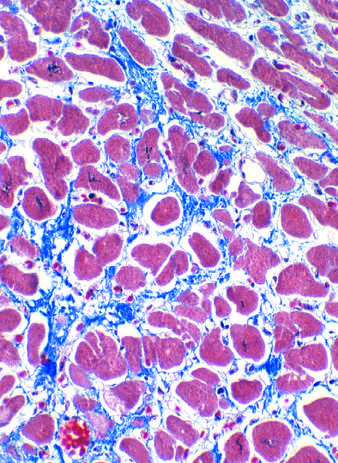what is blue in this masson trichrome-stained preparation?
Answer the question using a single word or phrase. Collagen 